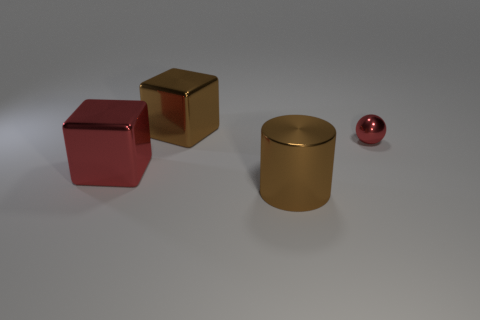What number of things have the same color as the metal ball?
Offer a very short reply. 1. How many other objects are there of the same color as the small metal sphere?
Provide a short and direct response. 1. There is a red metal object that is in front of the metallic sphere; what size is it?
Provide a succinct answer. Large. There is a shiny thing that is right of the large brown metallic cylinder; does it have the same color as the big cube on the right side of the big red block?
Ensure brevity in your answer.  No. There is a large block that is to the right of the shiny cube that is to the left of the big metal thing that is behind the big red metallic cube; what is it made of?
Offer a terse response. Metal. Are there any blue rubber cylinders that have the same size as the red shiny block?
Offer a terse response. No. What is the material of the cylinder that is the same size as the red metal block?
Offer a very short reply. Metal. What shape is the large brown metallic thing left of the brown cylinder?
Your answer should be very brief. Cube. Is the object that is behind the tiny object made of the same material as the big cylinder in front of the small sphere?
Offer a very short reply. Yes. How many large brown metallic objects are the same shape as the big red thing?
Your answer should be very brief. 1. 